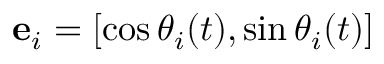Convert formula to latex. <formula><loc_0><loc_0><loc_500><loc_500>e _ { i } = [ \cos \theta _ { i } ( t ) , \sin \theta _ { i } ( t ) ]</formula> 